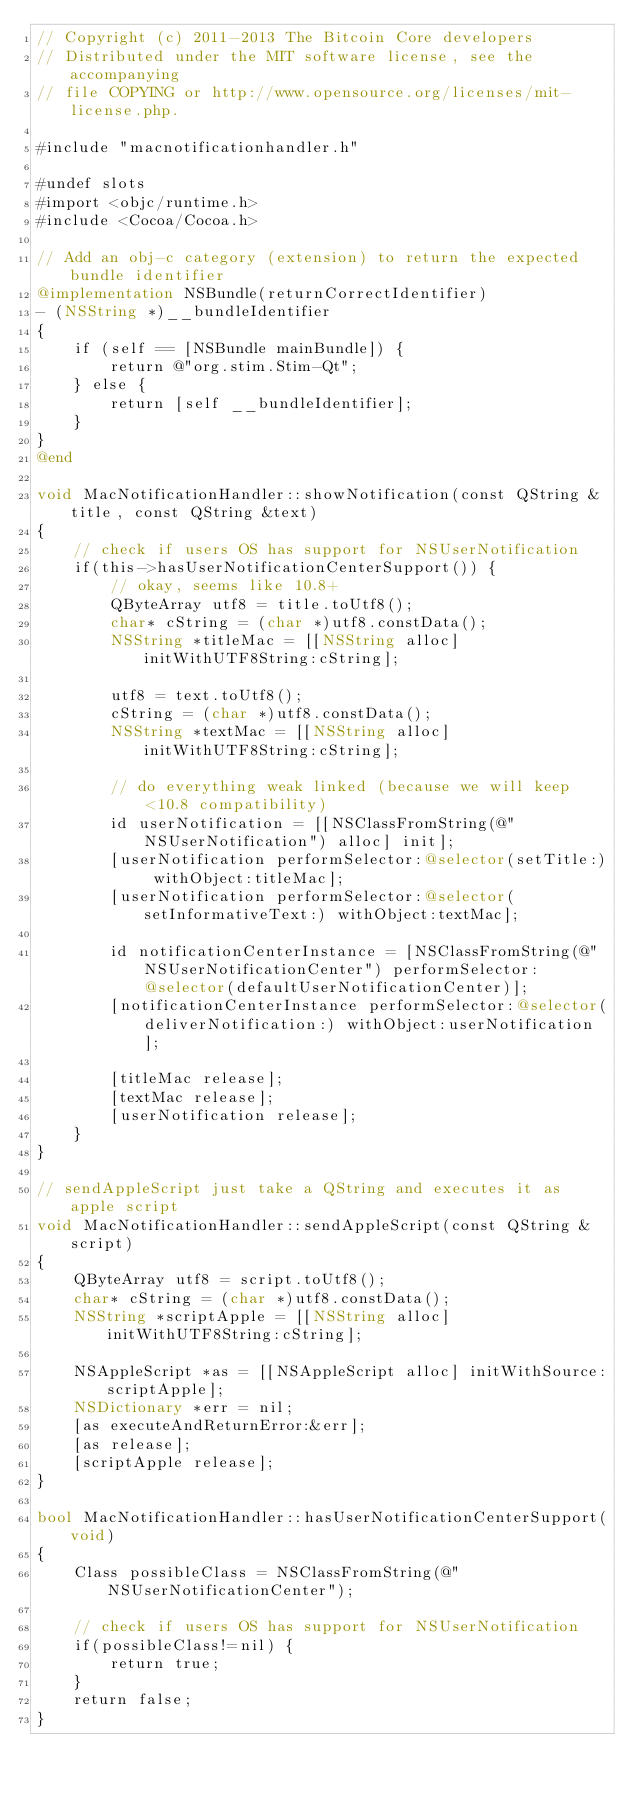Convert code to text. <code><loc_0><loc_0><loc_500><loc_500><_ObjectiveC_>// Copyright (c) 2011-2013 The Bitcoin Core developers
// Distributed under the MIT software license, see the accompanying
// file COPYING or http://www.opensource.org/licenses/mit-license.php.

#include "macnotificationhandler.h"

#undef slots
#import <objc/runtime.h>
#include <Cocoa/Cocoa.h>

// Add an obj-c category (extension) to return the expected bundle identifier
@implementation NSBundle(returnCorrectIdentifier)
- (NSString *)__bundleIdentifier
{
    if (self == [NSBundle mainBundle]) {
        return @"org.stim.Stim-Qt";
    } else {
        return [self __bundleIdentifier];
    }
}
@end

void MacNotificationHandler::showNotification(const QString &title, const QString &text)
{
    // check if users OS has support for NSUserNotification
    if(this->hasUserNotificationCenterSupport()) {
        // okay, seems like 10.8+
        QByteArray utf8 = title.toUtf8();
        char* cString = (char *)utf8.constData();
        NSString *titleMac = [[NSString alloc] initWithUTF8String:cString];

        utf8 = text.toUtf8();
        cString = (char *)utf8.constData();
        NSString *textMac = [[NSString alloc] initWithUTF8String:cString];

        // do everything weak linked (because we will keep <10.8 compatibility)
        id userNotification = [[NSClassFromString(@"NSUserNotification") alloc] init];
        [userNotification performSelector:@selector(setTitle:) withObject:titleMac];
        [userNotification performSelector:@selector(setInformativeText:) withObject:textMac];

        id notificationCenterInstance = [NSClassFromString(@"NSUserNotificationCenter") performSelector:@selector(defaultUserNotificationCenter)];
        [notificationCenterInstance performSelector:@selector(deliverNotification:) withObject:userNotification];

        [titleMac release];
        [textMac release];
        [userNotification release];
    }
}

// sendAppleScript just take a QString and executes it as apple script
void MacNotificationHandler::sendAppleScript(const QString &script)
{
    QByteArray utf8 = script.toUtf8();
    char* cString = (char *)utf8.constData();
    NSString *scriptApple = [[NSString alloc] initWithUTF8String:cString];

    NSAppleScript *as = [[NSAppleScript alloc] initWithSource:scriptApple];
    NSDictionary *err = nil;
    [as executeAndReturnError:&err];
    [as release];
    [scriptApple release];
}

bool MacNotificationHandler::hasUserNotificationCenterSupport(void)
{
    Class possibleClass = NSClassFromString(@"NSUserNotificationCenter");

    // check if users OS has support for NSUserNotification
    if(possibleClass!=nil) {
        return true;
    }
    return false;
}

</code> 